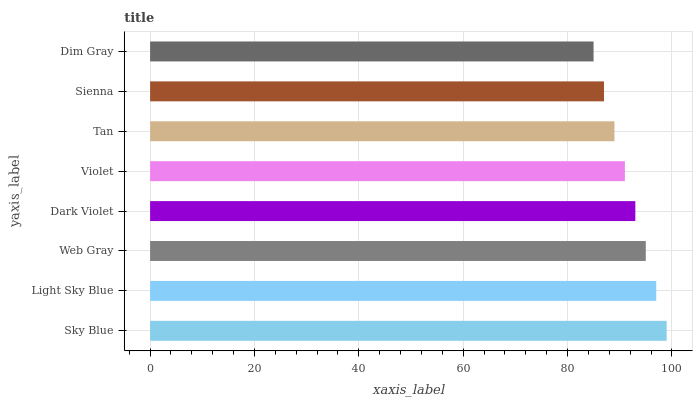Is Dim Gray the minimum?
Answer yes or no. Yes. Is Sky Blue the maximum?
Answer yes or no. Yes. Is Light Sky Blue the minimum?
Answer yes or no. No. Is Light Sky Blue the maximum?
Answer yes or no. No. Is Sky Blue greater than Light Sky Blue?
Answer yes or no. Yes. Is Light Sky Blue less than Sky Blue?
Answer yes or no. Yes. Is Light Sky Blue greater than Sky Blue?
Answer yes or no. No. Is Sky Blue less than Light Sky Blue?
Answer yes or no. No. Is Dark Violet the high median?
Answer yes or no. Yes. Is Violet the low median?
Answer yes or no. Yes. Is Violet the high median?
Answer yes or no. No. Is Dim Gray the low median?
Answer yes or no. No. 